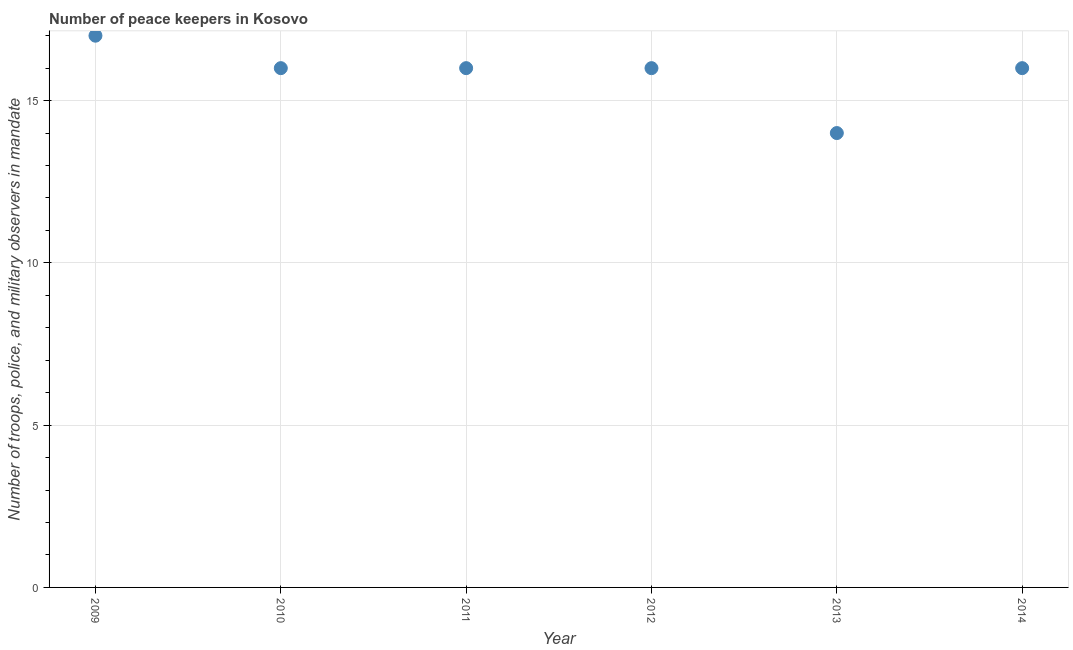What is the number of peace keepers in 2009?
Your response must be concise. 17. Across all years, what is the maximum number of peace keepers?
Your answer should be very brief. 17. Across all years, what is the minimum number of peace keepers?
Offer a very short reply. 14. In which year was the number of peace keepers maximum?
Your answer should be very brief. 2009. What is the sum of the number of peace keepers?
Provide a succinct answer. 95. What is the difference between the number of peace keepers in 2011 and 2013?
Your response must be concise. 2. What is the average number of peace keepers per year?
Offer a very short reply. 15.83. What is the median number of peace keepers?
Provide a succinct answer. 16. In how many years, is the number of peace keepers greater than 4 ?
Your answer should be compact. 6. What is the ratio of the number of peace keepers in 2012 to that in 2013?
Give a very brief answer. 1.14. Is the difference between the number of peace keepers in 2009 and 2013 greater than the difference between any two years?
Your response must be concise. Yes. Is the sum of the number of peace keepers in 2012 and 2014 greater than the maximum number of peace keepers across all years?
Make the answer very short. Yes. What is the difference between the highest and the lowest number of peace keepers?
Your answer should be very brief. 3. In how many years, is the number of peace keepers greater than the average number of peace keepers taken over all years?
Offer a very short reply. 5. Does the number of peace keepers monotonically increase over the years?
Give a very brief answer. No. How many dotlines are there?
Keep it short and to the point. 1. How many years are there in the graph?
Keep it short and to the point. 6. Are the values on the major ticks of Y-axis written in scientific E-notation?
Your answer should be compact. No. What is the title of the graph?
Give a very brief answer. Number of peace keepers in Kosovo. What is the label or title of the X-axis?
Give a very brief answer. Year. What is the label or title of the Y-axis?
Ensure brevity in your answer.  Number of troops, police, and military observers in mandate. What is the Number of troops, police, and military observers in mandate in 2009?
Your answer should be compact. 17. What is the Number of troops, police, and military observers in mandate in 2011?
Keep it short and to the point. 16. What is the Number of troops, police, and military observers in mandate in 2014?
Make the answer very short. 16. What is the difference between the Number of troops, police, and military observers in mandate in 2009 and 2010?
Your answer should be very brief. 1. What is the difference between the Number of troops, police, and military observers in mandate in 2009 and 2011?
Offer a terse response. 1. What is the difference between the Number of troops, police, and military observers in mandate in 2009 and 2012?
Keep it short and to the point. 1. What is the difference between the Number of troops, police, and military observers in mandate in 2009 and 2013?
Your response must be concise. 3. What is the difference between the Number of troops, police, and military observers in mandate in 2010 and 2014?
Offer a very short reply. 0. What is the difference between the Number of troops, police, and military observers in mandate in 2011 and 2014?
Ensure brevity in your answer.  0. What is the difference between the Number of troops, police, and military observers in mandate in 2013 and 2014?
Make the answer very short. -2. What is the ratio of the Number of troops, police, and military observers in mandate in 2009 to that in 2010?
Ensure brevity in your answer.  1.06. What is the ratio of the Number of troops, police, and military observers in mandate in 2009 to that in 2011?
Ensure brevity in your answer.  1.06. What is the ratio of the Number of troops, police, and military observers in mandate in 2009 to that in 2012?
Your answer should be very brief. 1.06. What is the ratio of the Number of troops, police, and military observers in mandate in 2009 to that in 2013?
Offer a very short reply. 1.21. What is the ratio of the Number of troops, police, and military observers in mandate in 2009 to that in 2014?
Your answer should be very brief. 1.06. What is the ratio of the Number of troops, police, and military observers in mandate in 2010 to that in 2013?
Make the answer very short. 1.14. What is the ratio of the Number of troops, police, and military observers in mandate in 2011 to that in 2012?
Provide a succinct answer. 1. What is the ratio of the Number of troops, police, and military observers in mandate in 2011 to that in 2013?
Your response must be concise. 1.14. What is the ratio of the Number of troops, police, and military observers in mandate in 2011 to that in 2014?
Your answer should be compact. 1. What is the ratio of the Number of troops, police, and military observers in mandate in 2012 to that in 2013?
Offer a very short reply. 1.14. What is the ratio of the Number of troops, police, and military observers in mandate in 2013 to that in 2014?
Your answer should be very brief. 0.88. 